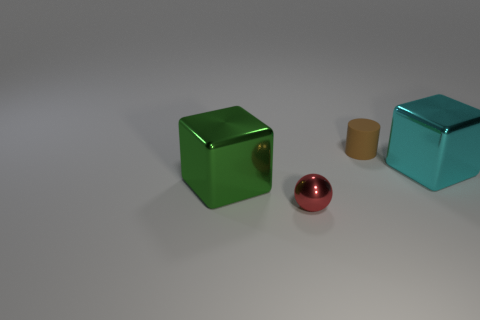What's the texture and lighting like in the scene? The scene has a very soft and diffused lighting, creating gentle shadows and subtle reflections on the surfaces of the objects, which appear to have smooth, shiny textures. 